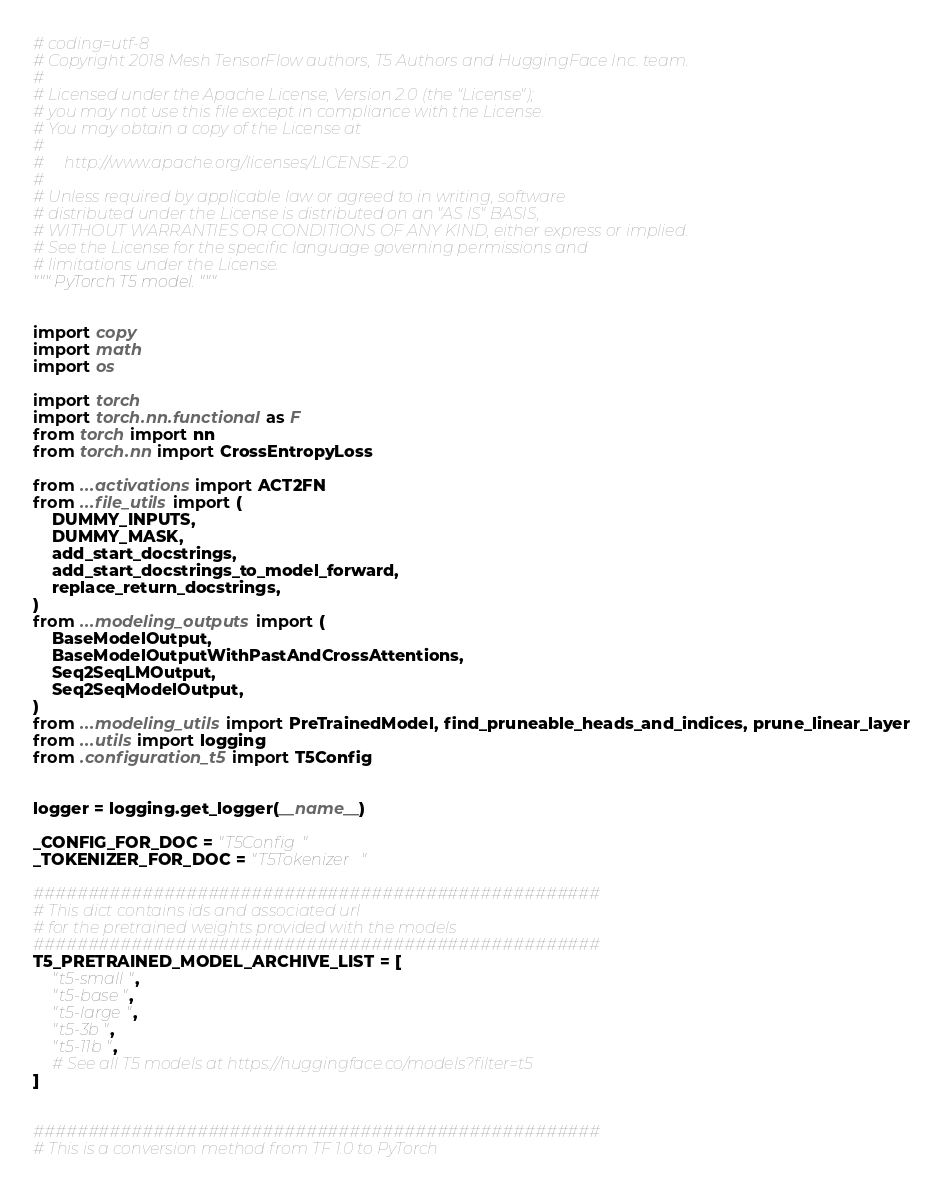<code> <loc_0><loc_0><loc_500><loc_500><_Python_># coding=utf-8
# Copyright 2018 Mesh TensorFlow authors, T5 Authors and HuggingFace Inc. team.
#
# Licensed under the Apache License, Version 2.0 (the "License");
# you may not use this file except in compliance with the License.
# You may obtain a copy of the License at
#
#     http://www.apache.org/licenses/LICENSE-2.0
#
# Unless required by applicable law or agreed to in writing, software
# distributed under the License is distributed on an "AS IS" BASIS,
# WITHOUT WARRANTIES OR CONDITIONS OF ANY KIND, either express or implied.
# See the License for the specific language governing permissions and
# limitations under the License.
""" PyTorch T5 model. """


import copy
import math
import os

import torch
import torch.nn.functional as F
from torch import nn
from torch.nn import CrossEntropyLoss

from ...activations import ACT2FN
from ...file_utils import (
    DUMMY_INPUTS,
    DUMMY_MASK,
    add_start_docstrings,
    add_start_docstrings_to_model_forward,
    replace_return_docstrings,
)
from ...modeling_outputs import (
    BaseModelOutput,
    BaseModelOutputWithPastAndCrossAttentions,
    Seq2SeqLMOutput,
    Seq2SeqModelOutput,
)
from ...modeling_utils import PreTrainedModel, find_pruneable_heads_and_indices, prune_linear_layer
from ...utils import logging
from .configuration_t5 import T5Config


logger = logging.get_logger(__name__)

_CONFIG_FOR_DOC = "T5Config"
_TOKENIZER_FOR_DOC = "T5Tokenizer"

####################################################
# This dict contains ids and associated url
# for the pretrained weights provided with the models
####################################################
T5_PRETRAINED_MODEL_ARCHIVE_LIST = [
    "t5-small",
    "t5-base",
    "t5-large",
    "t5-3b",
    "t5-11b",
    # See all T5 models at https://huggingface.co/models?filter=t5
]


####################################################
# This is a conversion method from TF 1.0 to PyTorch</code> 